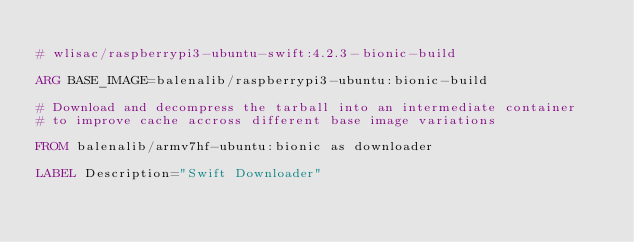Convert code to text. <code><loc_0><loc_0><loc_500><loc_500><_Dockerfile_>
# wlisac/raspberrypi3-ubuntu-swift:4.2.3-bionic-build

ARG BASE_IMAGE=balenalib/raspberrypi3-ubuntu:bionic-build

# Download and decompress the tarball into an intermediate container
# to improve cache accross different base image variations

FROM balenalib/armv7hf-ubuntu:bionic as downloader

LABEL Description="Swift Downloader"
</code> 